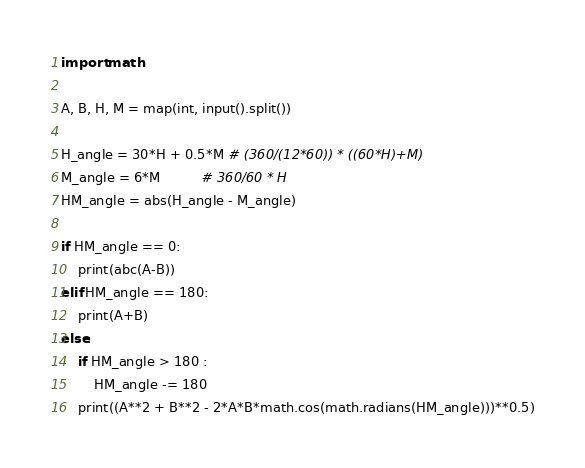<code> <loc_0><loc_0><loc_500><loc_500><_Python_>import math

A, B, H, M = map(int, input().split())

H_angle = 30*H + 0.5*M # (360/(12*60)) * ((60*H)+M)
M_angle = 6*M          # 360/60 * H
HM_angle = abs(H_angle - M_angle)

if HM_angle == 0:
    print(abc(A-B))
elif HM_angle == 180:
    print(A+B)
else:
    if HM_angle > 180 :
        HM_angle -= 180
    print((A**2 + B**2 - 2*A*B*math.cos(math.radians(HM_angle)))**0.5)</code> 